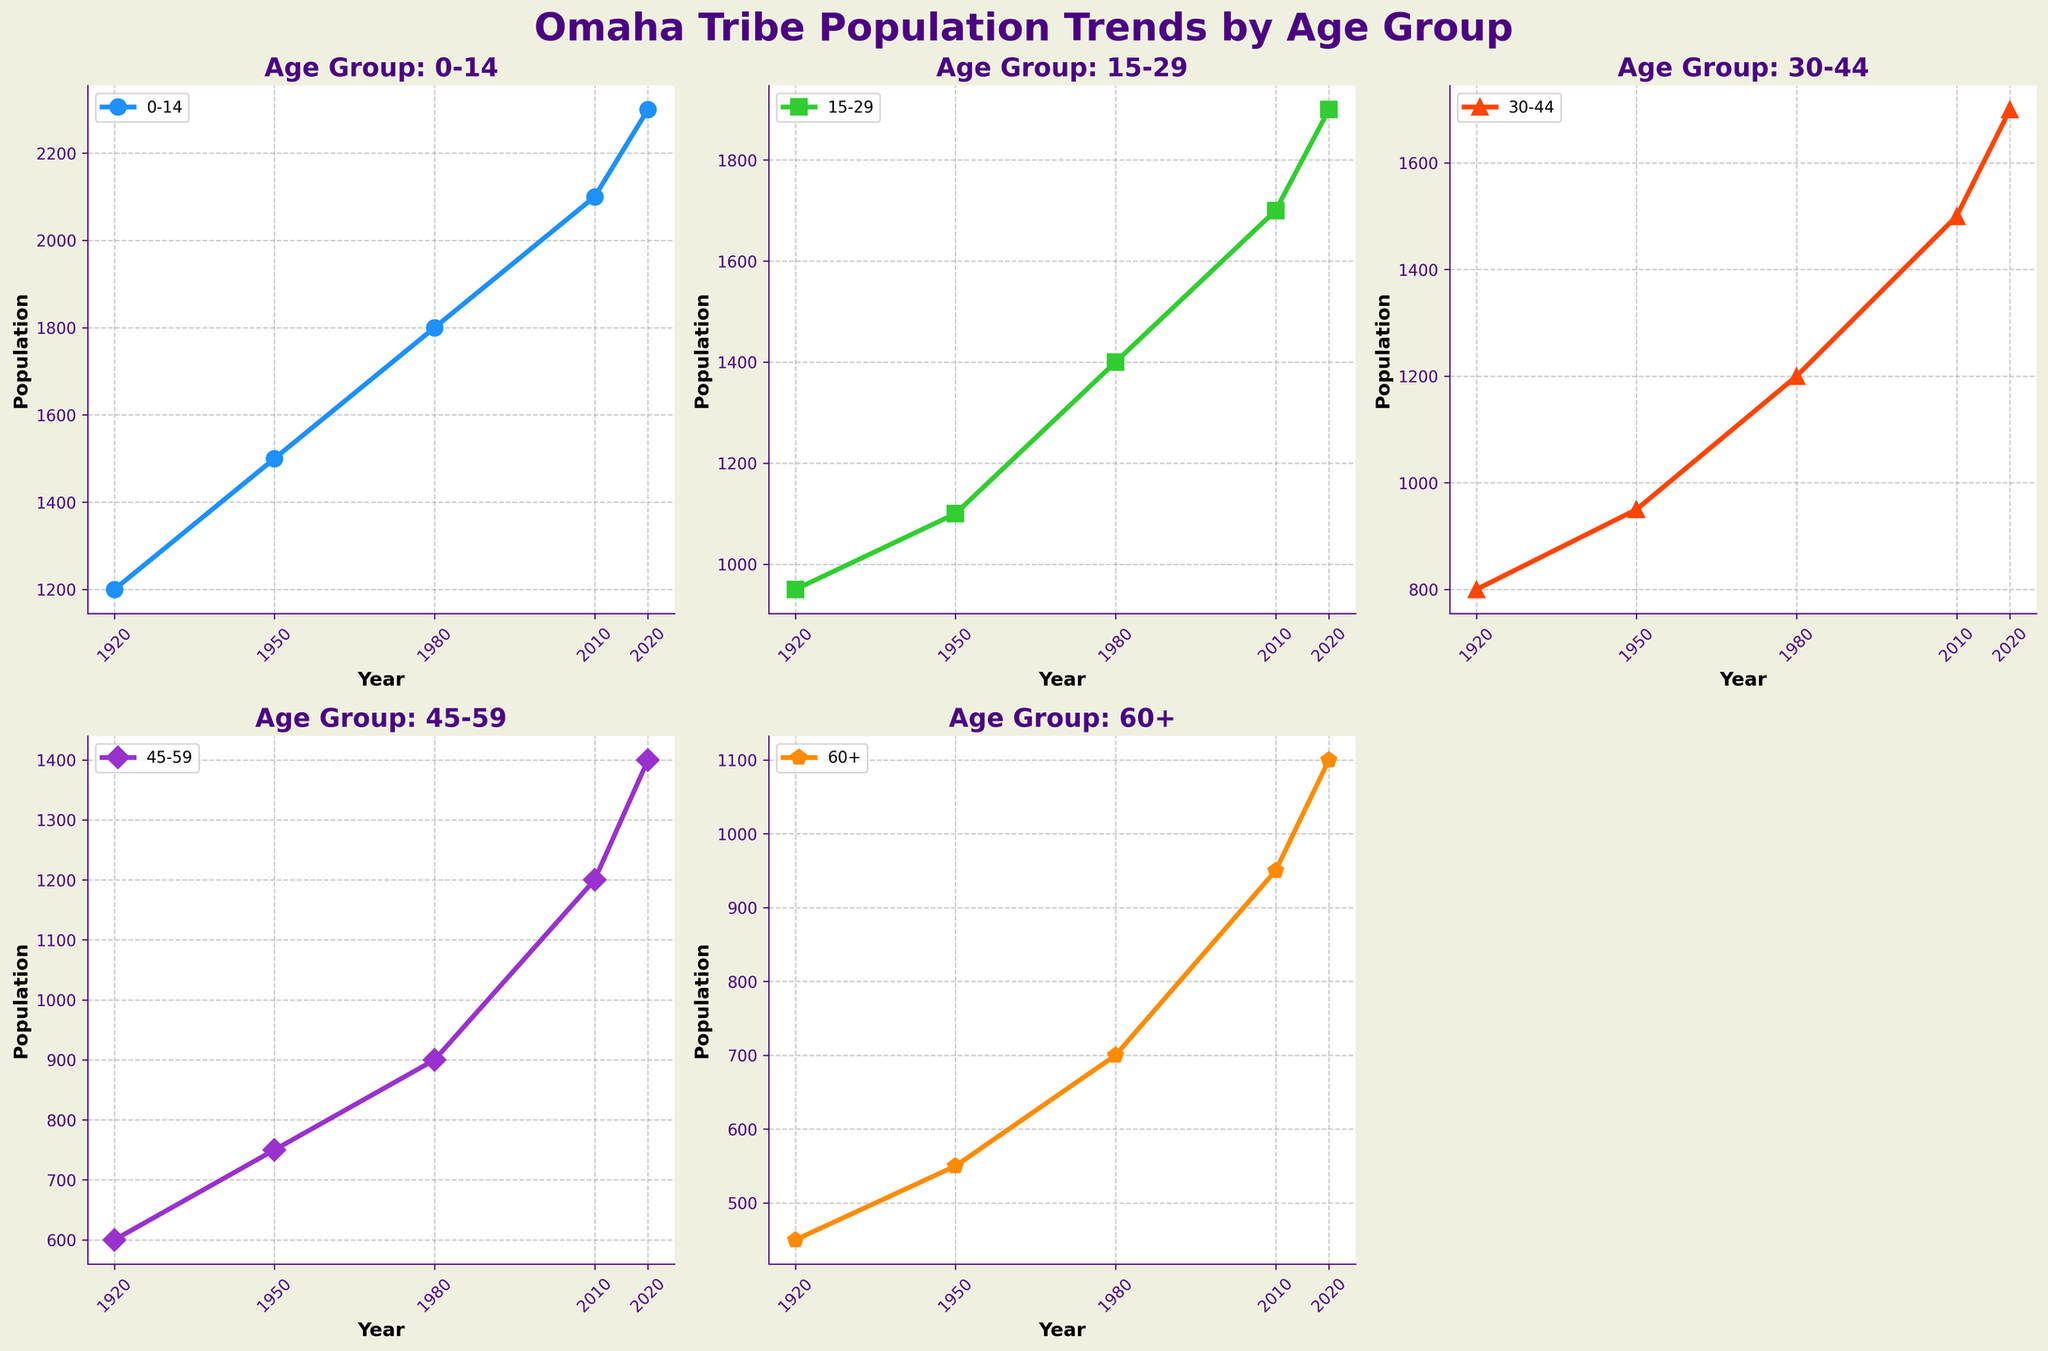What's the title of the figure? The title of the figure is displayed at the top in large, bold font.
Answer: Omaha Tribe Population Trends by Age Group What age group is represented by the purple line? Each age group is represented by a unique color. Observing the colors, the purple line corresponds to the '30-44' age group.
Answer: 30-44 Which age group had the highest population in 2020? By examining the data points for the year 2020, the age group with the highest population can be found. The '0-14' age group shows the highest value.
Answer: 0-14 Compare the populations of the 45-59 age group in 1920 and 2020. Which year had a higher population? Observing the values for the year 1920 and 2020 for the 45-59 age group, we see 600 for 1920 and 1400 for 2020. Therefore, 2020 had a higher population.
Answer: 2020 Which age group saw the most significant increase in population from 1950 to 2010? Calculate the difference in population for each age group between 1950 and 2010 and compare them. For the '0-14' age group, the increase is 2100 - 1500 = 600, which is the highest among all age groups.
Answer: 0-14 What is the average population of the 60+ age group over the decades shown in the plot? Average is calculated by summing the population values of each year for the 60+ group (450 + 550 + 700 + 950 + 1100) and dividing by the number of years, 5. The sum is 3750, and the average is 3750/5 = 750.
Answer: 750 Which age group's population remained below 1000 in all given years? By examining each subplot, we find that the 60+ age group's population values remained below 1000 in all listed years.
Answer: 60+ In 1980, which age group had the lowest population? From the data points in 1980, the '60+' age group shows the lowest population at 700.
Answer: 60+ How did the population of the 30-44 age group change from 1920 to 1980? The population of the '30-44' group in 1920 was 800 and in 1980 was 1200. The change is 1200 - 800 = 400.
Answer: 400 